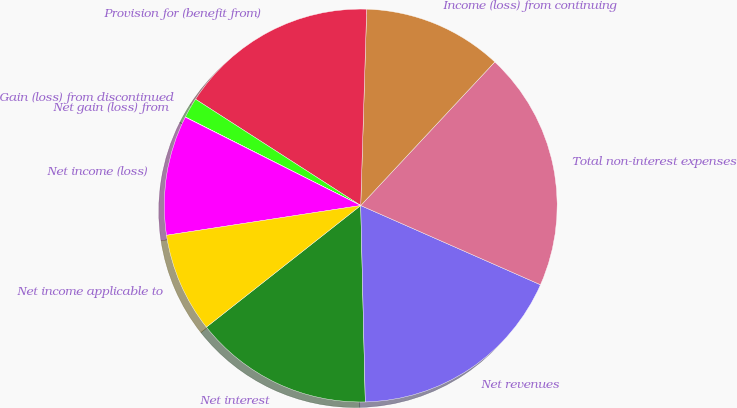Convert chart to OTSL. <chart><loc_0><loc_0><loc_500><loc_500><pie_chart><fcel>Net interest<fcel>Net revenues<fcel>Total non-interest expenses<fcel>Income (loss) from continuing<fcel>Provision for (benefit from)<fcel>Gain (loss) from discontinued<fcel>Net gain (loss) from<fcel>Net income (loss)<fcel>Net income applicable to<nl><fcel>14.75%<fcel>18.02%<fcel>19.65%<fcel>11.47%<fcel>16.38%<fcel>1.66%<fcel>0.02%<fcel>9.84%<fcel>8.2%<nl></chart> 